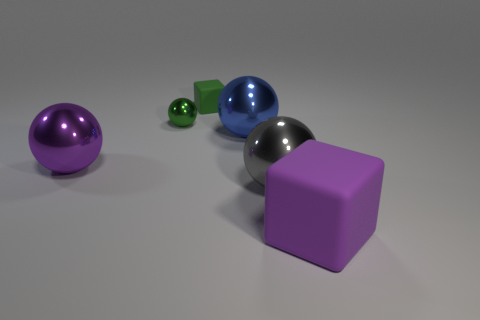Subtract all brown cubes. Subtract all green cylinders. How many cubes are left? 2 Add 1 tiny rubber blocks. How many objects exist? 7 Subtract all balls. How many objects are left? 2 Add 5 red matte cylinders. How many red matte cylinders exist? 5 Subtract 0 blue blocks. How many objects are left? 6 Subtract all purple cylinders. Subtract all small green spheres. How many objects are left? 5 Add 4 purple spheres. How many purple spheres are left? 5 